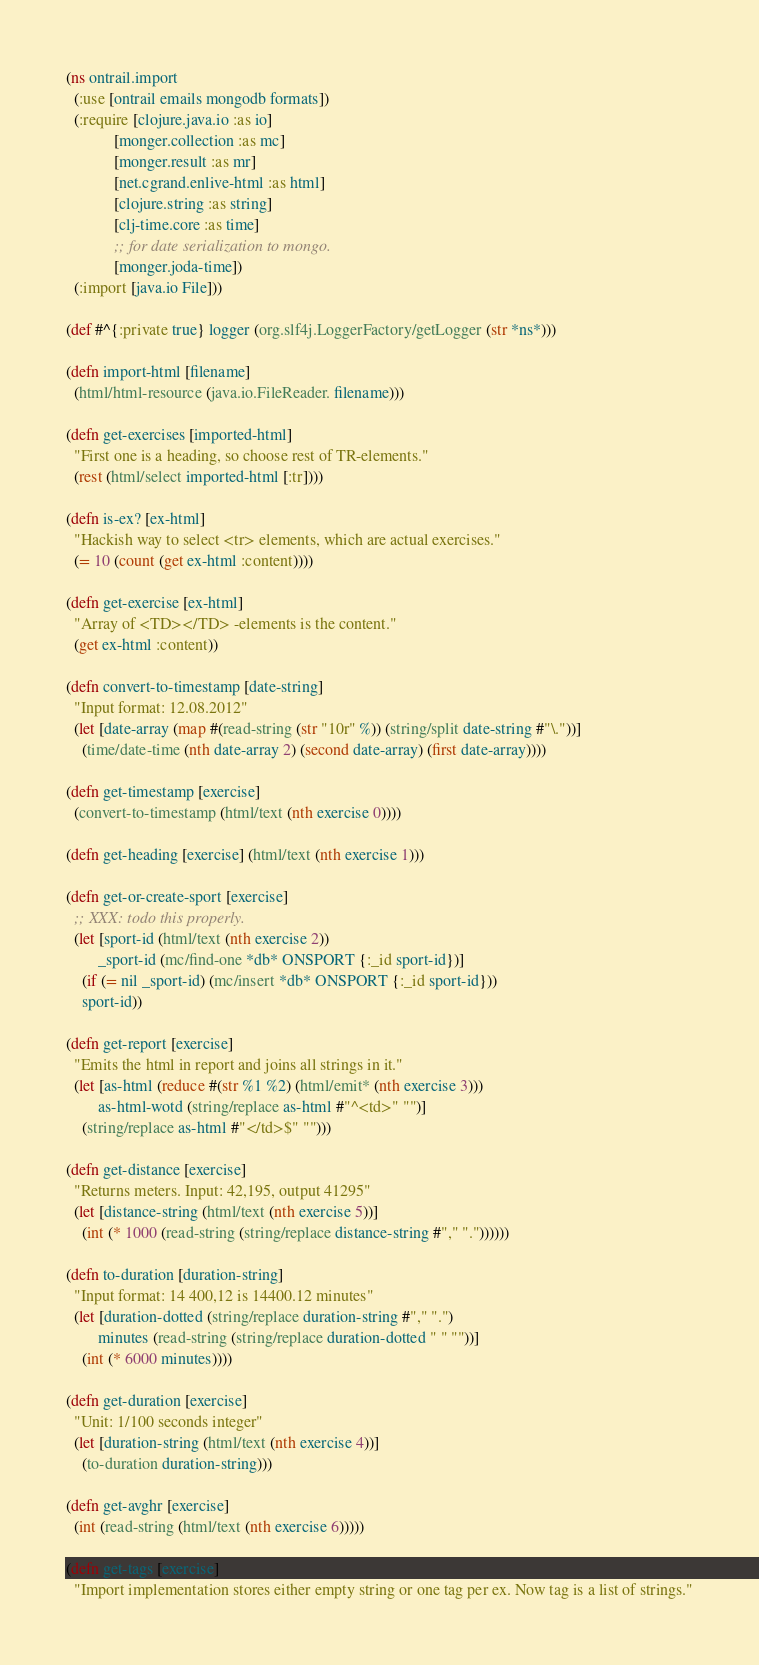<code> <loc_0><loc_0><loc_500><loc_500><_Clojure_>(ns ontrail.import
  (:use [ontrail emails mongodb formats])
  (:require [clojure.java.io :as io]
            [monger.collection :as mc]
            [monger.result :as mr]
            [net.cgrand.enlive-html :as html]
            [clojure.string :as string]
            [clj-time.core :as time]
            ;; for date serialization to mongo.
            [monger.joda-time])
  (:import [java.io File]))

(def #^{:private true} logger (org.slf4j.LoggerFactory/getLogger (str *ns*)))

(defn import-html [filename]
  (html/html-resource (java.io.FileReader. filename)))

(defn get-exercises [imported-html]
  "First one is a heading, so choose rest of TR-elements."
  (rest (html/select imported-html [:tr])))

(defn is-ex? [ex-html]
  "Hackish way to select <tr> elements, which are actual exercises."
  (= 10 (count (get ex-html :content))))

(defn get-exercise [ex-html]
  "Array of <TD></TD> -elements is the content."
  (get ex-html :content))

(defn convert-to-timestamp [date-string]
  "Input format: 12.08.2012"
  (let [date-array (map #(read-string (str "10r" %)) (string/split date-string #"\."))]
    (time/date-time (nth date-array 2) (second date-array) (first date-array))))

(defn get-timestamp [exercise]
  (convert-to-timestamp (html/text (nth exercise 0))))

(defn get-heading [exercise] (html/text (nth exercise 1)))

(defn get-or-create-sport [exercise]
  ;; XXX: todo this properly.
  (let [sport-id (html/text (nth exercise 2))
        _sport-id (mc/find-one *db* ONSPORT {:_id sport-id})]
    (if (= nil _sport-id) (mc/insert *db* ONSPORT {:_id sport-id}))
    sport-id))

(defn get-report [exercise]
  "Emits the html in report and joins all strings in it."
  (let [as-html (reduce #(str %1 %2) (html/emit* (nth exercise 3)))
        as-html-wotd (string/replace as-html #"^<td>" "")]
    (string/replace as-html #"</td>$" "")))

(defn get-distance [exercise]
  "Returns meters. Input: 42,195, output 41295"
  (let [distance-string (html/text (nth exercise 5))]
    (int (* 1000 (read-string (string/replace distance-string #"," "."))))))

(defn to-duration [duration-string]
  "Input format: 14 400,12 is 14400.12 minutes"
  (let [duration-dotted (string/replace duration-string #"," ".")
        minutes (read-string (string/replace duration-dotted " " ""))]
    (int (* 6000 minutes))))

(defn get-duration [exercise]
  "Unit: 1/100 seconds integer"
  (let [duration-string (html/text (nth exercise 4))]
    (to-duration duration-string)))

(defn get-avghr [exercise]
  (int (read-string (html/text (nth exercise 6)))))

(defn get-tags [exercise]
  "Import implementation stores either empty string or one tag per ex. Now tag is a list of strings."</code> 